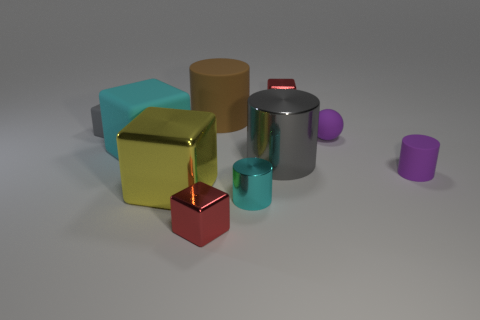Subtract all cyan blocks. How many blocks are left? 4 Subtract all yellow blocks. How many blocks are left? 4 Subtract all purple blocks. Subtract all green cylinders. How many blocks are left? 5 Subtract all cylinders. How many objects are left? 6 Subtract 0 blue cubes. How many objects are left? 10 Subtract all big purple spheres. Subtract all tiny purple cylinders. How many objects are left? 9 Add 3 cyan rubber objects. How many cyan rubber objects are left? 4 Add 10 green matte cylinders. How many green matte cylinders exist? 10 